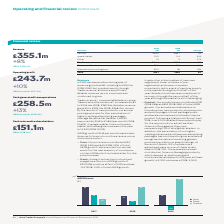According to Auto Trader's financial document, What was the percentage change in revenue growth in 2019 from 2018? According to the financial document, 8%. The relevant text states: "Trade 304.6 281.2 8%..." Also, What was the amount of Trade revenue in 2019? According to the financial document, £304.6m. The relevant text states: "ome Traders and other revenue – increased by 8% to £304.6m (2018: £281.2m). Retailer revenue grew 9% to £293.0m (2018: £268.7m), driven by the launch of new pr ome Traders and other revenue – increase..." Also, What were the components under Trade revenue? The document contains multiple relevant values: Retailer, Home trader, Other. From the document: "Retailer 293.0 268.7 9% Home trader 10.2 11.4 (11%) Other 1.4 1.1 27%..." Additionally, In which year was Consumer Services larger? According to the financial document, 2018. The relevant text states: "Revenue 2019 £m 2018 £m Change..." Also, can you calculate: What was the change in total revenue in 2019 from 2018? Based on the calculation: 355.1-330.1, the result is 25 (in millions). This is based on the information: "Total 355.1 330.1 8% Total 355.1 330.1 8%..." The key data points involved are: 330.1, 355.1. Also, can you calculate: What was the average total revenue in 2018 and 2019? To answer this question, I need to perform calculations using the financial data. The calculation is: (355.1+330.1)/2, which equals 342.6 (in millions). This is based on the information: "Total 355.1 330.1 8% Total 355.1 330.1 8%..." The key data points involved are: 330.1, 355.1. 